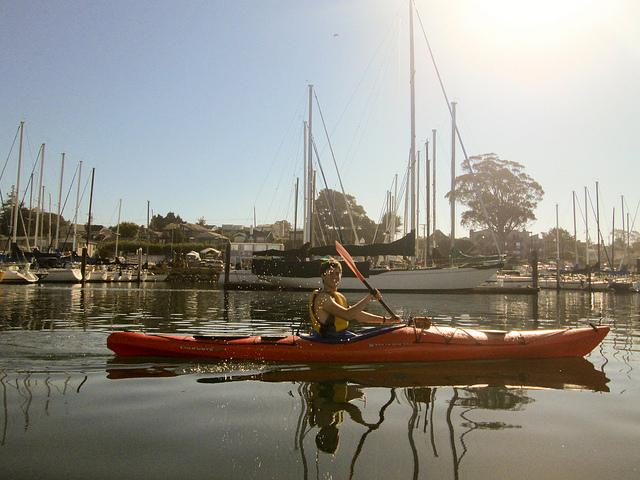What is the person riding in? kayak 